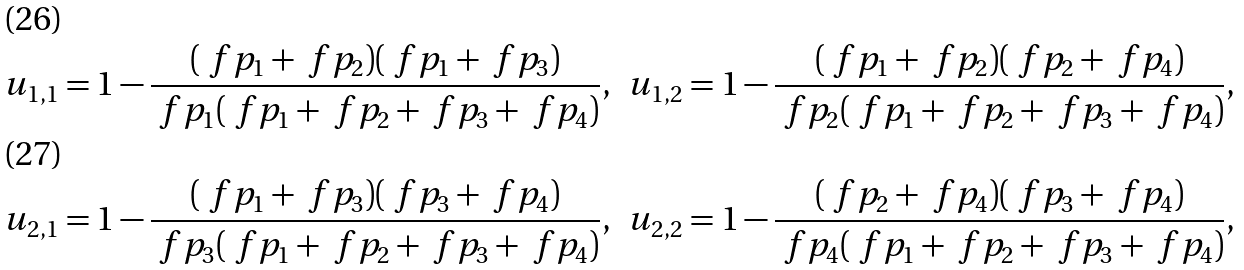<formula> <loc_0><loc_0><loc_500><loc_500>& u _ { 1 , 1 } = 1 - \frac { ( \ f p _ { 1 } + \ f p _ { 2 } ) ( \ f p _ { 1 } + \ f p _ { 3 } ) } { \ f p _ { 1 } ( \ f p _ { 1 } + \ f p _ { 2 } + \ f p _ { 3 } + \ f p _ { 4 } ) } , & & u _ { 1 , 2 } = 1 - \frac { ( \ f p _ { 1 } + \ f p _ { 2 } ) ( \ f p _ { 2 } + \ f p _ { 4 } ) } { \ f p _ { 2 } ( \ f p _ { 1 } + \ f p _ { 2 } + \ f p _ { 3 } + \ f p _ { 4 } ) } , \\ & u _ { 2 , 1 } = 1 - \frac { ( \ f p _ { 1 } + \ f p _ { 3 } ) ( \ f p _ { 3 } + \ f p _ { 4 } ) } { \ f p _ { 3 } ( \ f p _ { 1 } + \ f p _ { 2 } + \ f p _ { 3 } + \ f p _ { 4 } ) } , & & u _ { 2 , 2 } = 1 - \frac { ( \ f p _ { 2 } + \ f p _ { 4 } ) ( \ f p _ { 3 } + \ f p _ { 4 } ) } { \ f p _ { 4 } ( \ f p _ { 1 } + \ f p _ { 2 } + \ f p _ { 3 } + \ f p _ { 4 } ) } ,</formula> 